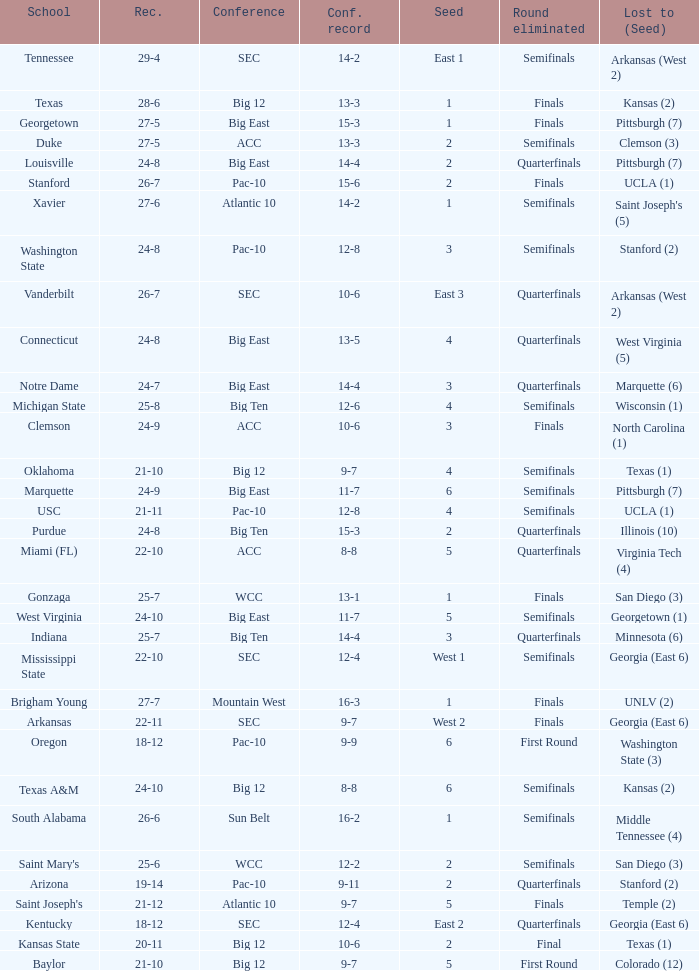Would you mind parsing the complete table? {'header': ['School', 'Rec.', 'Conference', 'Conf. record', 'Seed', 'Round eliminated', 'Lost to (Seed)'], 'rows': [['Tennessee', '29-4', 'SEC', '14-2', 'East 1', 'Semifinals', 'Arkansas (West 2)'], ['Texas', '28-6', 'Big 12', '13-3', '1', 'Finals', 'Kansas (2)'], ['Georgetown', '27-5', 'Big East', '15-3', '1', 'Finals', 'Pittsburgh (7)'], ['Duke', '27-5', 'ACC', '13-3', '2', 'Semifinals', 'Clemson (3)'], ['Louisville', '24-8', 'Big East', '14-4', '2', 'Quarterfinals', 'Pittsburgh (7)'], ['Stanford', '26-7', 'Pac-10', '15-6', '2', 'Finals', 'UCLA (1)'], ['Xavier', '27-6', 'Atlantic 10', '14-2', '1', 'Semifinals', "Saint Joseph's (5)"], ['Washington State', '24-8', 'Pac-10', '12-8', '3', 'Semifinals', 'Stanford (2)'], ['Vanderbilt', '26-7', 'SEC', '10-6', 'East 3', 'Quarterfinals', 'Arkansas (West 2)'], ['Connecticut', '24-8', 'Big East', '13-5', '4', 'Quarterfinals', 'West Virginia (5)'], ['Notre Dame', '24-7', 'Big East', '14-4', '3', 'Quarterfinals', 'Marquette (6)'], ['Michigan State', '25-8', 'Big Ten', '12-6', '4', 'Semifinals', 'Wisconsin (1)'], ['Clemson', '24-9', 'ACC', '10-6', '3', 'Finals', 'North Carolina (1)'], ['Oklahoma', '21-10', 'Big 12', '9-7', '4', 'Semifinals', 'Texas (1)'], ['Marquette', '24-9', 'Big East', '11-7', '6', 'Semifinals', 'Pittsburgh (7)'], ['USC', '21-11', 'Pac-10', '12-8', '4', 'Semifinals', 'UCLA (1)'], ['Purdue', '24-8', 'Big Ten', '15-3', '2', 'Quarterfinals', 'Illinois (10)'], ['Miami (FL)', '22-10', 'ACC', '8-8', '5', 'Quarterfinals', 'Virginia Tech (4)'], ['Gonzaga', '25-7', 'WCC', '13-1', '1', 'Finals', 'San Diego (3)'], ['West Virginia', '24-10', 'Big East', '11-7', '5', 'Semifinals', 'Georgetown (1)'], ['Indiana', '25-7', 'Big Ten', '14-4', '3', 'Quarterfinals', 'Minnesota (6)'], ['Mississippi State', '22-10', 'SEC', '12-4', 'West 1', 'Semifinals', 'Georgia (East 6)'], ['Brigham Young', '27-7', 'Mountain West', '16-3', '1', 'Finals', 'UNLV (2)'], ['Arkansas', '22-11', 'SEC', '9-7', 'West 2', 'Finals', 'Georgia (East 6)'], ['Oregon', '18-12', 'Pac-10', '9-9', '6', 'First Round', 'Washington State (3)'], ['Texas A&M', '24-10', 'Big 12', '8-8', '6', 'Semifinals', 'Kansas (2)'], ['South Alabama', '26-6', 'Sun Belt', '16-2', '1', 'Semifinals', 'Middle Tennessee (4)'], ["Saint Mary's", '25-6', 'WCC', '12-2', '2', 'Semifinals', 'San Diego (3)'], ['Arizona', '19-14', 'Pac-10', '9-11', '2', 'Quarterfinals', 'Stanford (2)'], ["Saint Joseph's", '21-12', 'Atlantic 10', '9-7', '5', 'Finals', 'Temple (2)'], ['Kentucky', '18-12', 'SEC', '12-4', 'East 2', 'Quarterfinals', 'Georgia (East 6)'], ['Kansas State', '20-11', 'Big 12', '10-6', '2', 'Final', 'Texas (1)'], ['Baylor', '21-10', 'Big 12', '9-7', '5', 'First Round', 'Colorado (12)']]} Name the school where conference record is 12-6 Michigan State. 